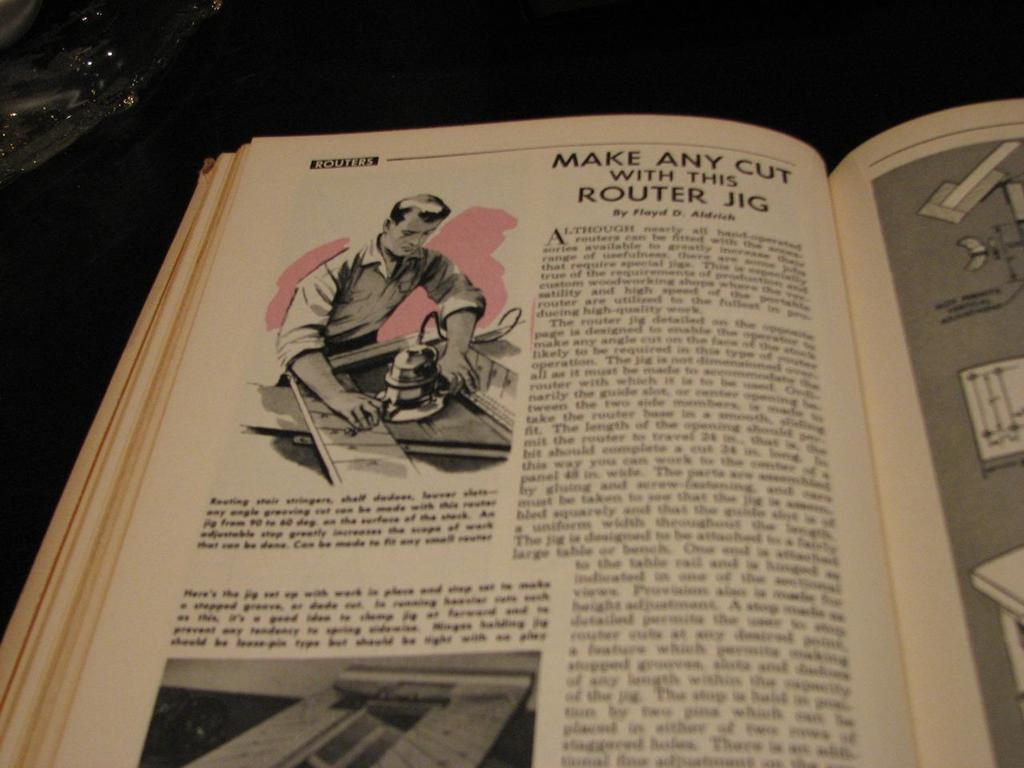Please provide a concise description of this image. In this image in the center there is a book and on the book are some text written and there are images. 